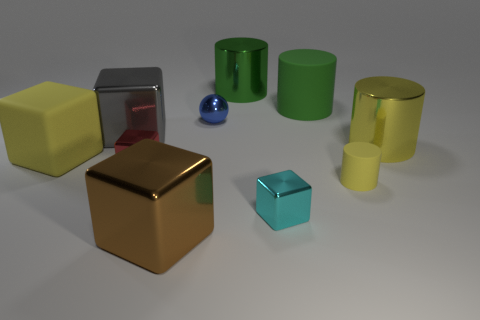Subtract all yellow metal cylinders. How many cylinders are left? 3 Subtract all yellow cylinders. How many cylinders are left? 2 Subtract all cyan spheres. How many green cylinders are left? 2 Subtract all cylinders. How many objects are left? 6 Subtract 3 cubes. How many cubes are left? 2 Subtract all big yellow rubber things. Subtract all large metallic cubes. How many objects are left? 7 Add 2 big green metal cylinders. How many big green metal cylinders are left? 3 Add 9 large cyan metal cubes. How many large cyan metal cubes exist? 9 Subtract 0 purple blocks. How many objects are left? 10 Subtract all yellow blocks. Subtract all red balls. How many blocks are left? 4 